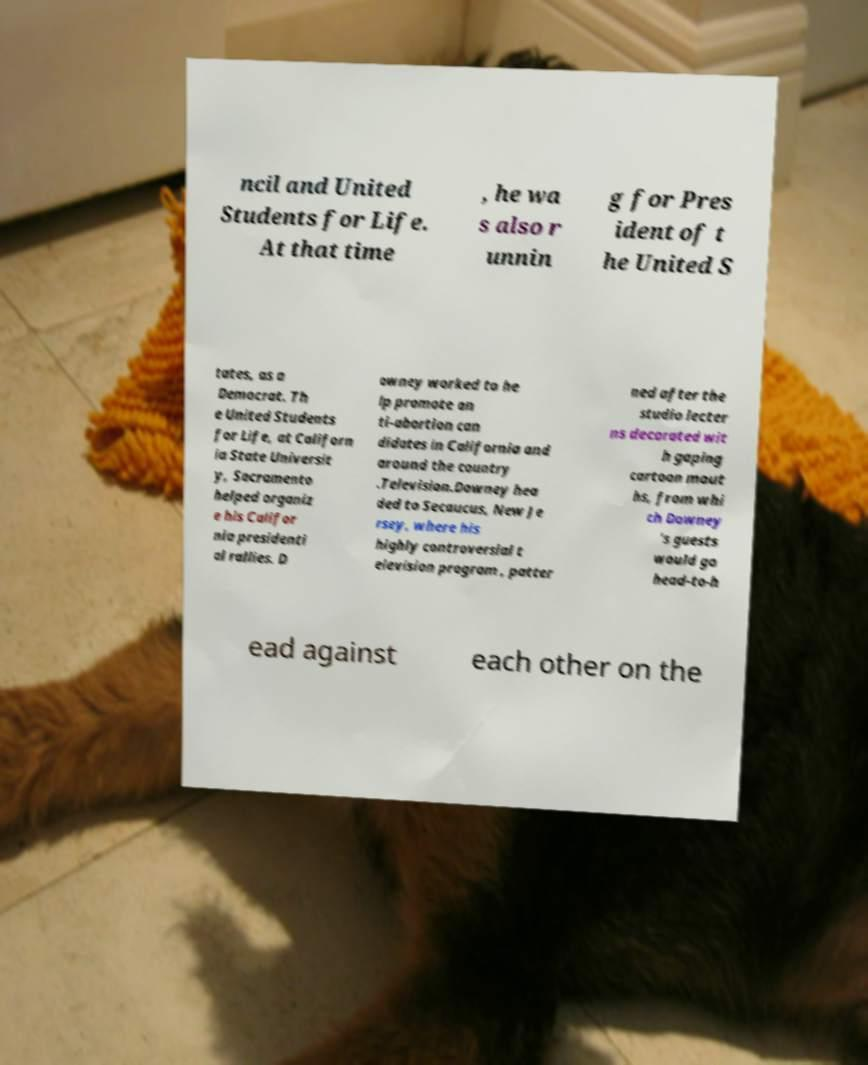Can you accurately transcribe the text from the provided image for me? ncil and United Students for Life. At that time , he wa s also r unnin g for Pres ident of t he United S tates, as a Democrat. Th e United Students for Life, at Californ ia State Universit y, Sacramento helped organiz e his Califor nia presidenti al rallies. D owney worked to he lp promote an ti-abortion can didates in California and around the country .Television.Downey hea ded to Secaucus, New Je rsey, where his highly controversial t elevision program , patter ned after the studio lecter ns decorated wit h gaping cartoon mout hs, from whi ch Downey 's guests would go head-to-h ead against each other on the 